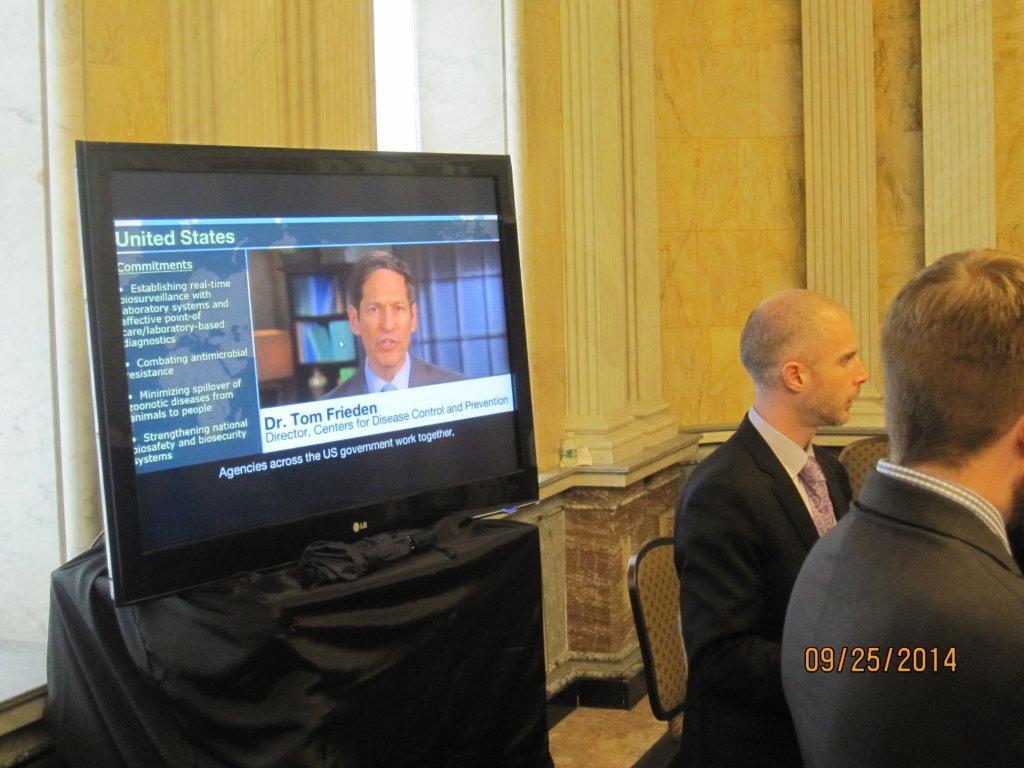What country is the television host discussing?
Offer a very short reply. United states. What is the name of the doctor?
Keep it short and to the point. Tom frieden. 